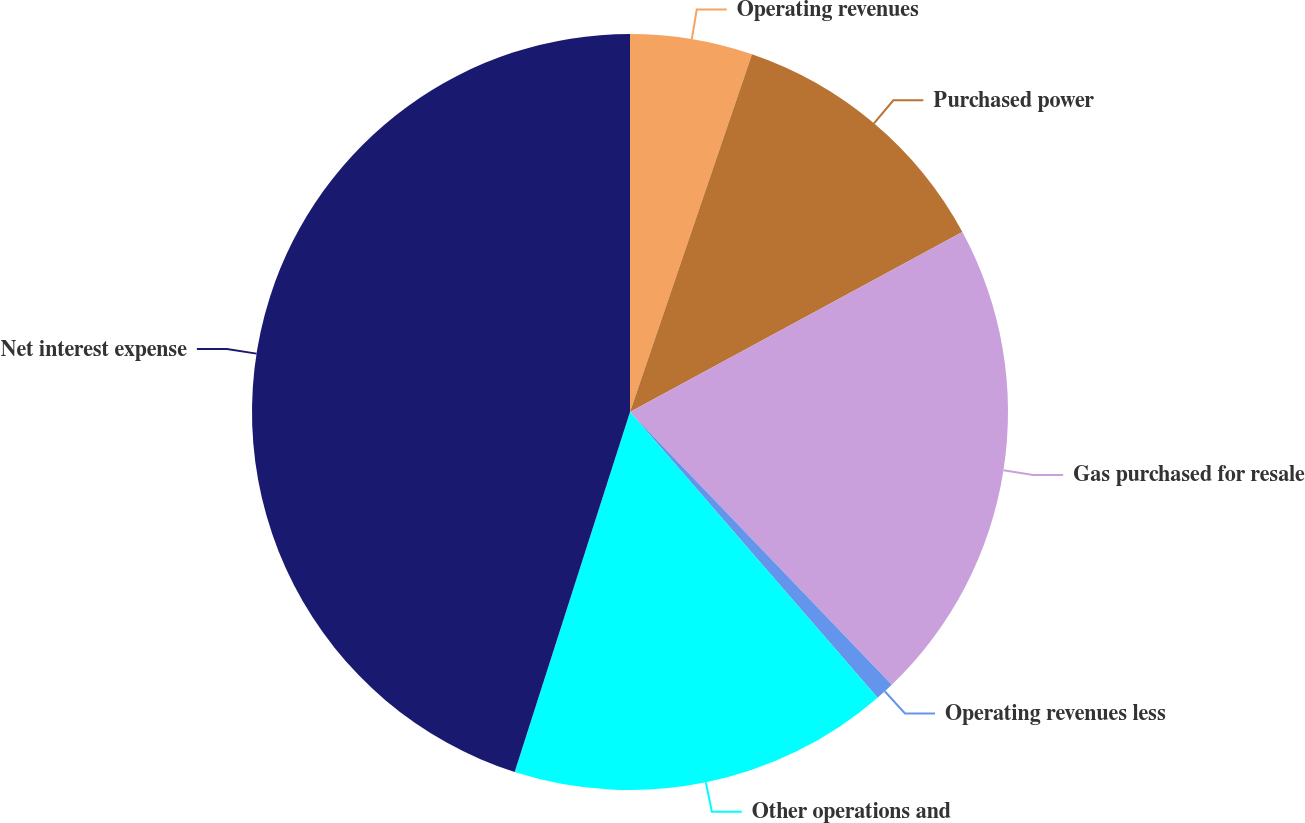Convert chart to OTSL. <chart><loc_0><loc_0><loc_500><loc_500><pie_chart><fcel>Operating revenues<fcel>Purchased power<fcel>Gas purchased for resale<fcel>Operating revenues less<fcel>Other operations and<fcel>Net interest expense<nl><fcel>5.23%<fcel>11.87%<fcel>20.72%<fcel>0.81%<fcel>16.3%<fcel>45.06%<nl></chart> 